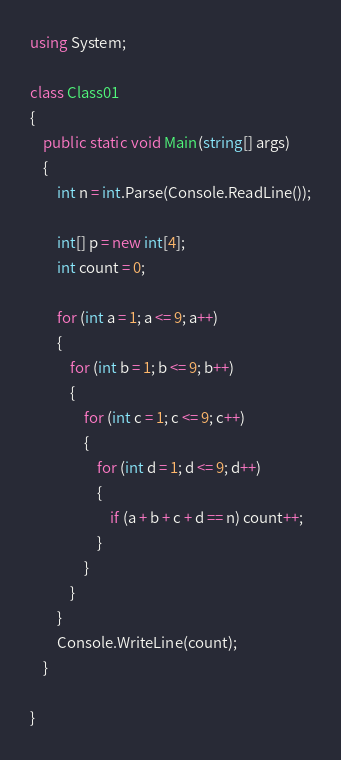Convert code to text. <code><loc_0><loc_0><loc_500><loc_500><_C#_>using System;

class Class01
{
    public static void Main(string[] args)
    {
        int n = int.Parse(Console.ReadLine());

        int[] p = new int[4];
        int count = 0;

        for (int a = 1; a <= 9; a++)
        {
            for (int b = 1; b <= 9; b++)
            {
                for (int c = 1; c <= 9; c++)
                {
                    for (int d = 1; d <= 9; d++)
                    {
                        if (a + b + c + d == n) count++;
                    }
                }
            }
        }
        Console.WriteLine(count);
    }

}</code> 